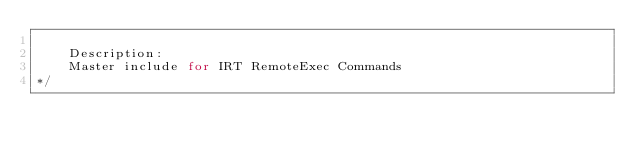Convert code to text. <code><loc_0><loc_0><loc_500><loc_500><_C++_>
    Description:
    Master include for IRT RemoteExec Commands
*/</code> 